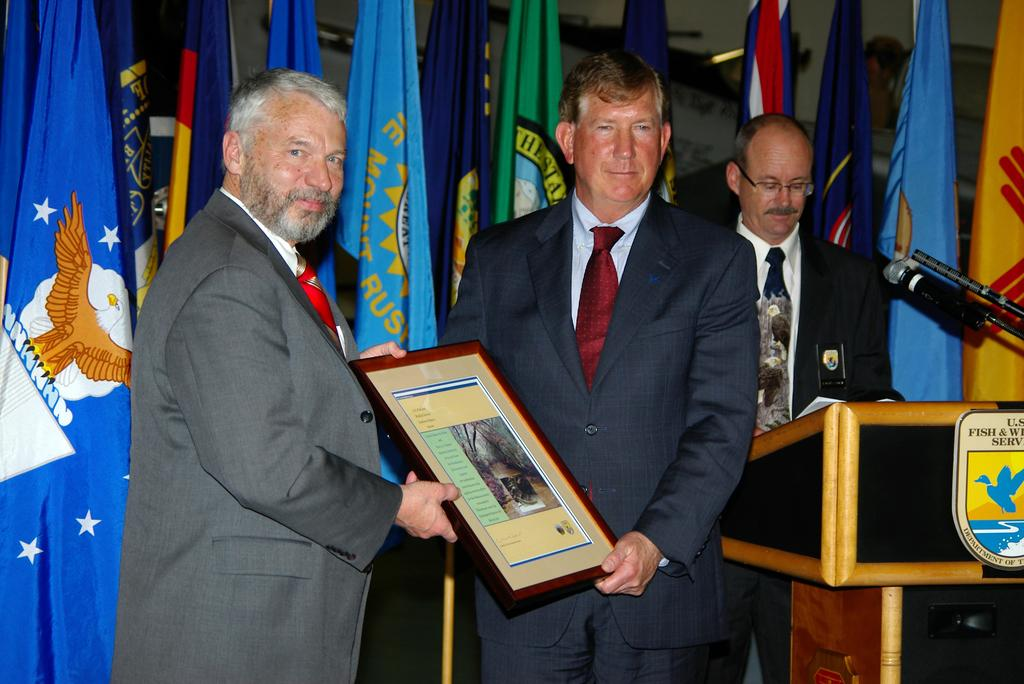Who or what can be seen in the image? There are people in the image. What object is related to the people in the image? There is an award in the image. What device is present for amplifying sound? There is a microphone (mike) in the image. What national symbols are visible in the image? There are flags in the image. What piece of furniture is present in the image? There is a desk in the image. What caption is written on the park bench in the image? There is no park bench or caption present in the image. 